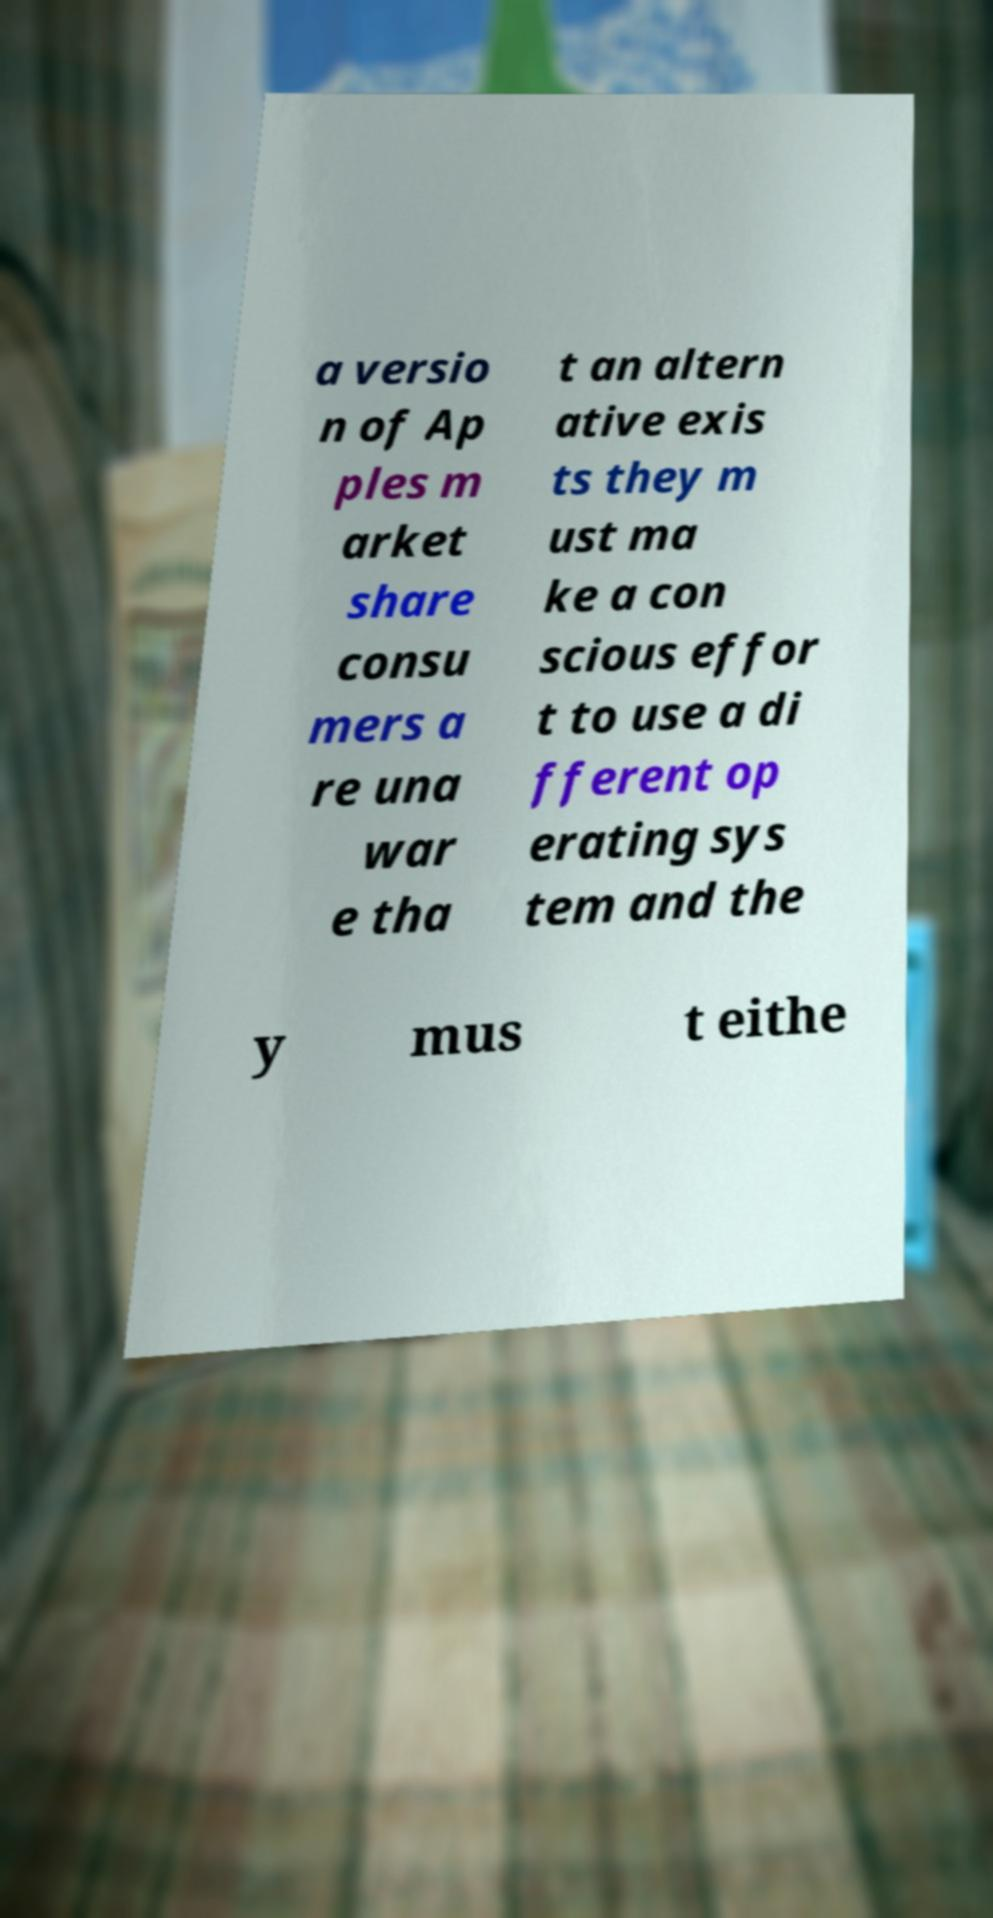I need the written content from this picture converted into text. Can you do that? a versio n of Ap ples m arket share consu mers a re una war e tha t an altern ative exis ts they m ust ma ke a con scious effor t to use a di fferent op erating sys tem and the y mus t eithe 